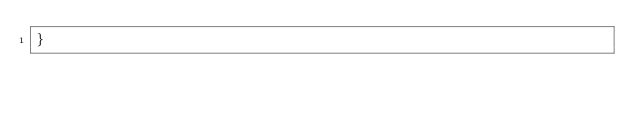<code> <loc_0><loc_0><loc_500><loc_500><_CSS_>}
</code> 